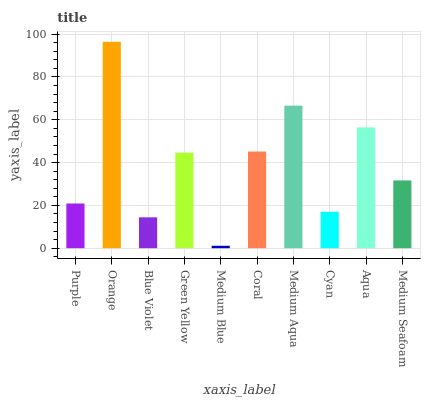Is Medium Blue the minimum?
Answer yes or no. Yes. Is Orange the maximum?
Answer yes or no. Yes. Is Blue Violet the minimum?
Answer yes or no. No. Is Blue Violet the maximum?
Answer yes or no. No. Is Orange greater than Blue Violet?
Answer yes or no. Yes. Is Blue Violet less than Orange?
Answer yes or no. Yes. Is Blue Violet greater than Orange?
Answer yes or no. No. Is Orange less than Blue Violet?
Answer yes or no. No. Is Green Yellow the high median?
Answer yes or no. Yes. Is Medium Seafoam the low median?
Answer yes or no. Yes. Is Blue Violet the high median?
Answer yes or no. No. Is Coral the low median?
Answer yes or no. No. 